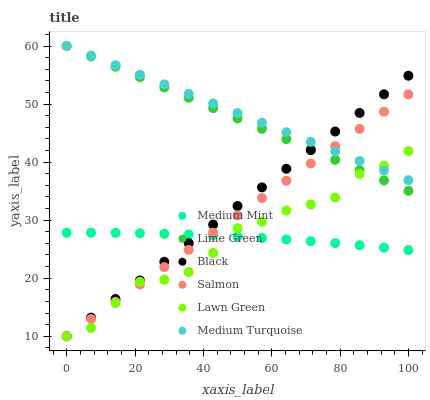Does Lawn Green have the minimum area under the curve?
Answer yes or no. Yes. Does Medium Turquoise have the maximum area under the curve?
Answer yes or no. Yes. Does Salmon have the minimum area under the curve?
Answer yes or no. No. Does Salmon have the maximum area under the curve?
Answer yes or no. No. Is Lime Green the smoothest?
Answer yes or no. Yes. Is Lawn Green the roughest?
Answer yes or no. Yes. Is Salmon the smoothest?
Answer yes or no. No. Is Salmon the roughest?
Answer yes or no. No. Does Lawn Green have the lowest value?
Answer yes or no. Yes. Does Medium Turquoise have the lowest value?
Answer yes or no. No. Does Lime Green have the highest value?
Answer yes or no. Yes. Does Lawn Green have the highest value?
Answer yes or no. No. Is Medium Mint less than Lime Green?
Answer yes or no. Yes. Is Lime Green greater than Medium Mint?
Answer yes or no. Yes. Does Lawn Green intersect Salmon?
Answer yes or no. Yes. Is Lawn Green less than Salmon?
Answer yes or no. No. Is Lawn Green greater than Salmon?
Answer yes or no. No. Does Medium Mint intersect Lime Green?
Answer yes or no. No. 